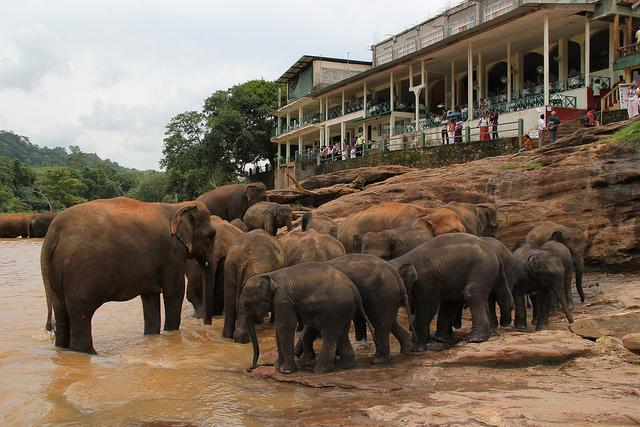What keeps the elephants out of the buildings? rocks 